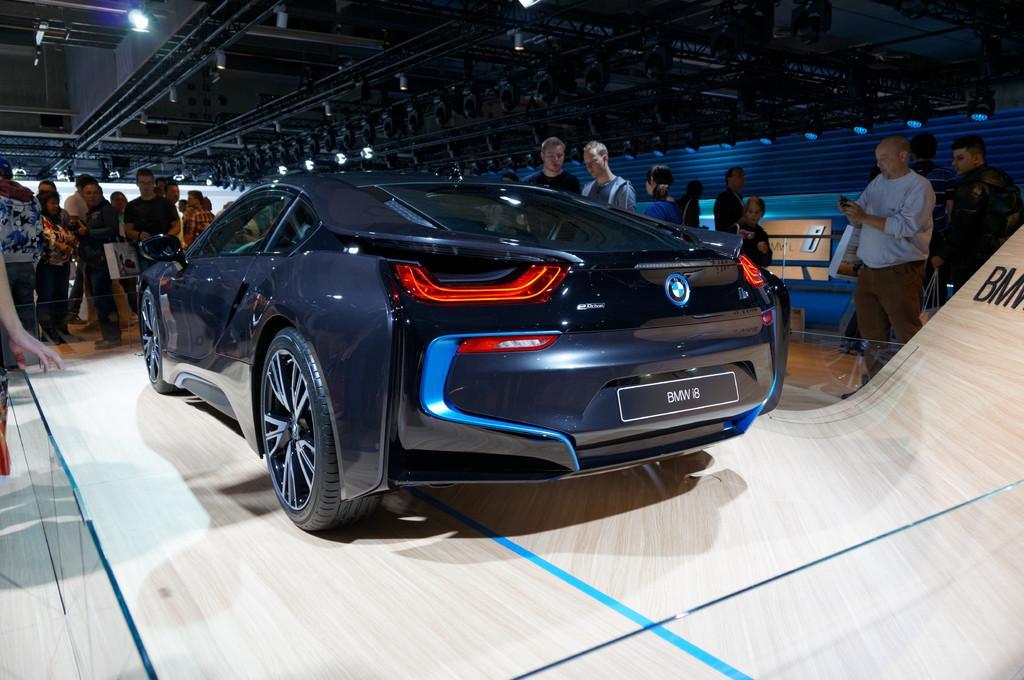In one or two sentences, can you explain what this image depicts? In this image we can see people, a vehicle, lights, boards and objects under the shed. Among them few people are holding objects. Something is written on the boards.   